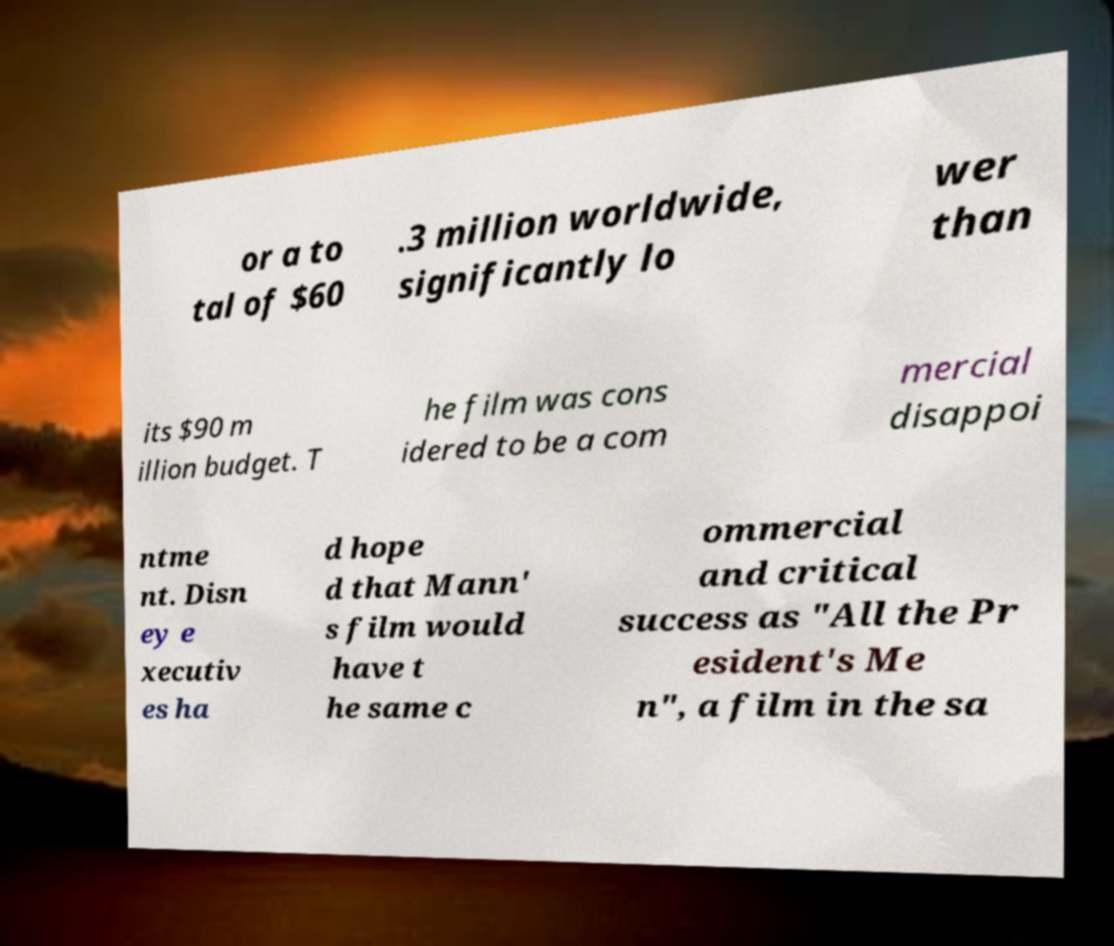Please read and relay the text visible in this image. What does it say? or a to tal of $60 .3 million worldwide, significantly lo wer than its $90 m illion budget. T he film was cons idered to be a com mercial disappoi ntme nt. Disn ey e xecutiv es ha d hope d that Mann' s film would have t he same c ommercial and critical success as "All the Pr esident's Me n", a film in the sa 